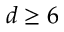Convert formula to latex. <formula><loc_0><loc_0><loc_500><loc_500>d \geq 6</formula> 